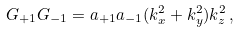<formula> <loc_0><loc_0><loc_500><loc_500>G _ { + 1 } G _ { - 1 } = a _ { + 1 } a _ { - 1 } ( k _ { x } ^ { 2 } + k _ { y } ^ { 2 } ) k _ { z } ^ { 2 } \, ,</formula> 